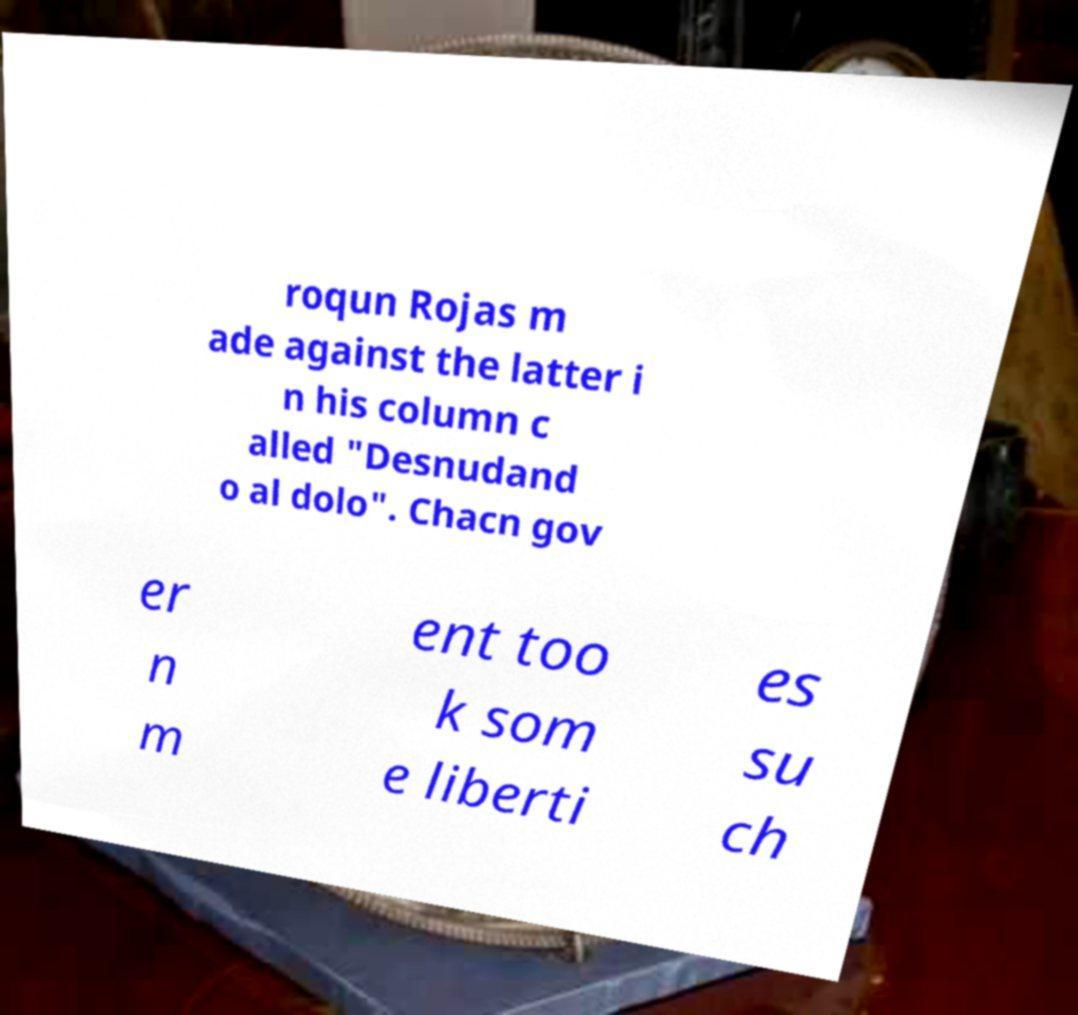For documentation purposes, I need the text within this image transcribed. Could you provide that? roqun Rojas m ade against the latter i n his column c alled "Desnudand o al dolo". Chacn gov er n m ent too k som e liberti es su ch 